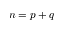Convert formula to latex. <formula><loc_0><loc_0><loc_500><loc_500>n = p + q</formula> 